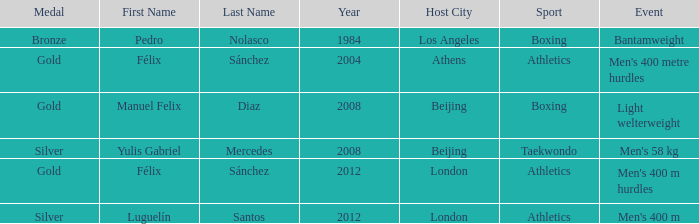Which medal was won in the 2008 beijing games in the category of taekwondo? Silver. 